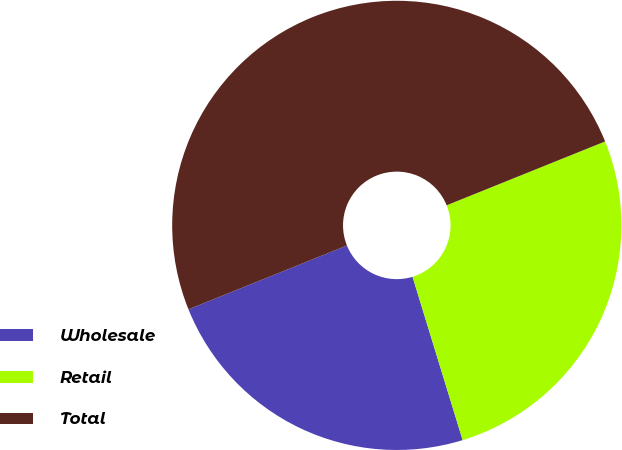<chart> <loc_0><loc_0><loc_500><loc_500><pie_chart><fcel>Wholesale<fcel>Retail<fcel>Total<nl><fcel>23.64%<fcel>26.36%<fcel>50.0%<nl></chart> 